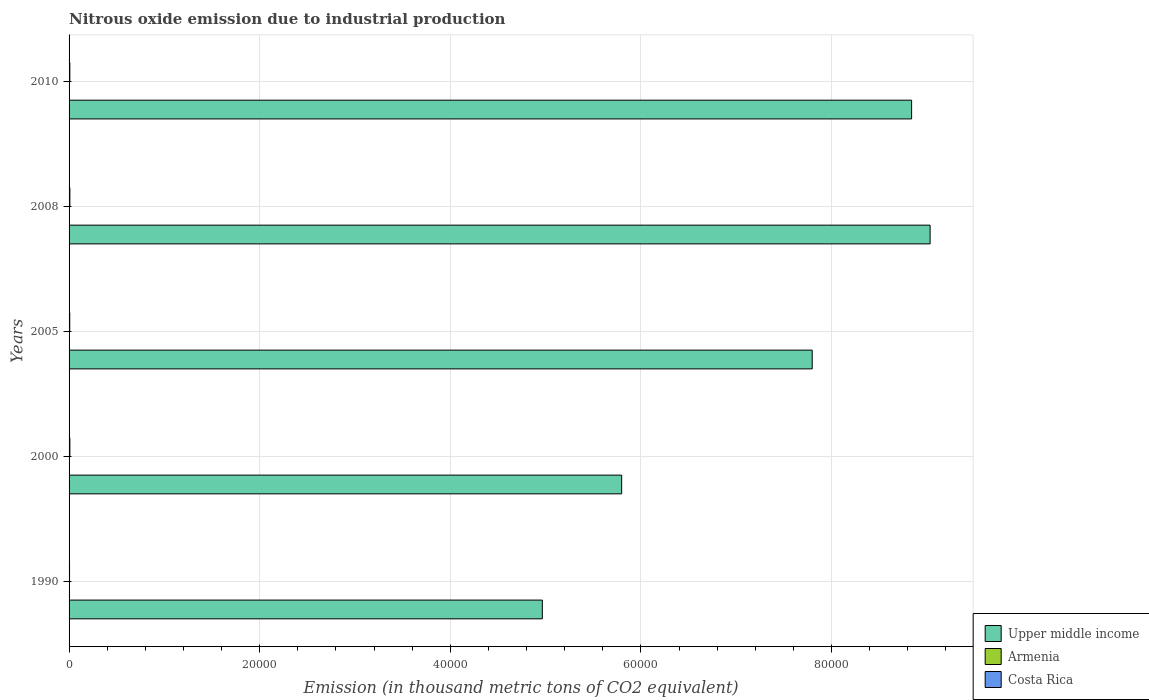How many groups of bars are there?
Provide a succinct answer. 5. Are the number of bars on each tick of the Y-axis equal?
Your answer should be very brief. Yes. How many bars are there on the 3rd tick from the top?
Your answer should be compact. 3. How many bars are there on the 5th tick from the bottom?
Make the answer very short. 3. What is the label of the 2nd group of bars from the top?
Provide a short and direct response. 2008. What is the amount of nitrous oxide emitted in Upper middle income in 2008?
Your response must be concise. 9.03e+04. Across all years, what is the maximum amount of nitrous oxide emitted in Costa Rica?
Provide a succinct answer. 83.4. Across all years, what is the minimum amount of nitrous oxide emitted in Costa Rica?
Your response must be concise. 50.5. What is the total amount of nitrous oxide emitted in Upper middle income in the graph?
Your response must be concise. 3.64e+05. What is the difference between the amount of nitrous oxide emitted in Upper middle income in 2000 and that in 2005?
Your answer should be compact. -2.00e+04. What is the difference between the amount of nitrous oxide emitted in Costa Rica in 2010 and the amount of nitrous oxide emitted in Armenia in 2000?
Your answer should be compact. 75.6. What is the average amount of nitrous oxide emitted in Costa Rica per year?
Give a very brief answer. 73.76. In the year 2008, what is the difference between the amount of nitrous oxide emitted in Costa Rica and amount of nitrous oxide emitted in Armenia?
Ensure brevity in your answer.  59.7. In how many years, is the amount of nitrous oxide emitted in Costa Rica greater than 40000 thousand metric tons?
Ensure brevity in your answer.  0. What is the ratio of the amount of nitrous oxide emitted in Upper middle income in 2000 to that in 2008?
Your response must be concise. 0.64. Is the amount of nitrous oxide emitted in Upper middle income in 1990 less than that in 2005?
Make the answer very short. Yes. Is the difference between the amount of nitrous oxide emitted in Costa Rica in 1990 and 2008 greater than the difference between the amount of nitrous oxide emitted in Armenia in 1990 and 2008?
Offer a very short reply. No. What is the difference between the highest and the second highest amount of nitrous oxide emitted in Armenia?
Keep it short and to the point. 13.3. What is the difference between the highest and the lowest amount of nitrous oxide emitted in Upper middle income?
Provide a succinct answer. 4.07e+04. What does the 2nd bar from the top in 1990 represents?
Offer a terse response. Armenia. What does the 1st bar from the bottom in 2000 represents?
Your answer should be very brief. Upper middle income. Is it the case that in every year, the sum of the amount of nitrous oxide emitted in Armenia and amount of nitrous oxide emitted in Upper middle income is greater than the amount of nitrous oxide emitted in Costa Rica?
Provide a succinct answer. Yes. Are all the bars in the graph horizontal?
Offer a very short reply. Yes. Are the values on the major ticks of X-axis written in scientific E-notation?
Your answer should be compact. No. Does the graph contain any zero values?
Your response must be concise. No. Where does the legend appear in the graph?
Ensure brevity in your answer.  Bottom right. How many legend labels are there?
Offer a very short reply. 3. What is the title of the graph?
Your answer should be very brief. Nitrous oxide emission due to industrial production. Does "Zimbabwe" appear as one of the legend labels in the graph?
Make the answer very short. No. What is the label or title of the X-axis?
Offer a terse response. Emission (in thousand metric tons of CO2 equivalent). What is the label or title of the Y-axis?
Your answer should be very brief. Years. What is the Emission (in thousand metric tons of CO2 equivalent) of Upper middle income in 1990?
Keep it short and to the point. 4.97e+04. What is the Emission (in thousand metric tons of CO2 equivalent) in Costa Rica in 1990?
Keep it short and to the point. 50.5. What is the Emission (in thousand metric tons of CO2 equivalent) of Upper middle income in 2000?
Your answer should be very brief. 5.80e+04. What is the Emission (in thousand metric tons of CO2 equivalent) of Costa Rica in 2000?
Make the answer very short. 83.4. What is the Emission (in thousand metric tons of CO2 equivalent) in Upper middle income in 2005?
Provide a succinct answer. 7.80e+04. What is the Emission (in thousand metric tons of CO2 equivalent) of Armenia in 2005?
Offer a terse response. 5.8. What is the Emission (in thousand metric tons of CO2 equivalent) of Costa Rica in 2005?
Give a very brief answer. 70.7. What is the Emission (in thousand metric tons of CO2 equivalent) of Upper middle income in 2008?
Your answer should be very brief. 9.03e+04. What is the Emission (in thousand metric tons of CO2 equivalent) of Armenia in 2008?
Keep it short and to the point. 23.7. What is the Emission (in thousand metric tons of CO2 equivalent) in Costa Rica in 2008?
Keep it short and to the point. 83.4. What is the Emission (in thousand metric tons of CO2 equivalent) of Upper middle income in 2010?
Provide a short and direct response. 8.84e+04. What is the Emission (in thousand metric tons of CO2 equivalent) of Armenia in 2010?
Provide a succinct answer. 22.8. What is the Emission (in thousand metric tons of CO2 equivalent) of Costa Rica in 2010?
Provide a succinct answer. 80.8. Across all years, what is the maximum Emission (in thousand metric tons of CO2 equivalent) in Upper middle income?
Your answer should be compact. 9.03e+04. Across all years, what is the maximum Emission (in thousand metric tons of CO2 equivalent) of Armenia?
Offer a very short reply. 37. Across all years, what is the maximum Emission (in thousand metric tons of CO2 equivalent) of Costa Rica?
Offer a terse response. 83.4. Across all years, what is the minimum Emission (in thousand metric tons of CO2 equivalent) of Upper middle income?
Keep it short and to the point. 4.97e+04. Across all years, what is the minimum Emission (in thousand metric tons of CO2 equivalent) in Costa Rica?
Offer a very short reply. 50.5. What is the total Emission (in thousand metric tons of CO2 equivalent) of Upper middle income in the graph?
Offer a very short reply. 3.64e+05. What is the total Emission (in thousand metric tons of CO2 equivalent) in Armenia in the graph?
Provide a succinct answer. 94.5. What is the total Emission (in thousand metric tons of CO2 equivalent) in Costa Rica in the graph?
Provide a short and direct response. 368.8. What is the difference between the Emission (in thousand metric tons of CO2 equivalent) of Upper middle income in 1990 and that in 2000?
Your response must be concise. -8322.4. What is the difference between the Emission (in thousand metric tons of CO2 equivalent) in Armenia in 1990 and that in 2000?
Provide a succinct answer. 31.8. What is the difference between the Emission (in thousand metric tons of CO2 equivalent) in Costa Rica in 1990 and that in 2000?
Keep it short and to the point. -32.9. What is the difference between the Emission (in thousand metric tons of CO2 equivalent) in Upper middle income in 1990 and that in 2005?
Ensure brevity in your answer.  -2.83e+04. What is the difference between the Emission (in thousand metric tons of CO2 equivalent) in Armenia in 1990 and that in 2005?
Provide a succinct answer. 31.2. What is the difference between the Emission (in thousand metric tons of CO2 equivalent) in Costa Rica in 1990 and that in 2005?
Provide a short and direct response. -20.2. What is the difference between the Emission (in thousand metric tons of CO2 equivalent) of Upper middle income in 1990 and that in 2008?
Offer a terse response. -4.07e+04. What is the difference between the Emission (in thousand metric tons of CO2 equivalent) of Costa Rica in 1990 and that in 2008?
Your response must be concise. -32.9. What is the difference between the Emission (in thousand metric tons of CO2 equivalent) of Upper middle income in 1990 and that in 2010?
Your answer should be compact. -3.87e+04. What is the difference between the Emission (in thousand metric tons of CO2 equivalent) in Costa Rica in 1990 and that in 2010?
Make the answer very short. -30.3. What is the difference between the Emission (in thousand metric tons of CO2 equivalent) in Upper middle income in 2000 and that in 2005?
Keep it short and to the point. -2.00e+04. What is the difference between the Emission (in thousand metric tons of CO2 equivalent) of Costa Rica in 2000 and that in 2005?
Provide a short and direct response. 12.7. What is the difference between the Emission (in thousand metric tons of CO2 equivalent) of Upper middle income in 2000 and that in 2008?
Your answer should be very brief. -3.24e+04. What is the difference between the Emission (in thousand metric tons of CO2 equivalent) of Armenia in 2000 and that in 2008?
Provide a succinct answer. -18.5. What is the difference between the Emission (in thousand metric tons of CO2 equivalent) in Costa Rica in 2000 and that in 2008?
Give a very brief answer. 0. What is the difference between the Emission (in thousand metric tons of CO2 equivalent) of Upper middle income in 2000 and that in 2010?
Ensure brevity in your answer.  -3.04e+04. What is the difference between the Emission (in thousand metric tons of CO2 equivalent) in Armenia in 2000 and that in 2010?
Make the answer very short. -17.6. What is the difference between the Emission (in thousand metric tons of CO2 equivalent) of Costa Rica in 2000 and that in 2010?
Give a very brief answer. 2.6. What is the difference between the Emission (in thousand metric tons of CO2 equivalent) in Upper middle income in 2005 and that in 2008?
Ensure brevity in your answer.  -1.24e+04. What is the difference between the Emission (in thousand metric tons of CO2 equivalent) in Armenia in 2005 and that in 2008?
Ensure brevity in your answer.  -17.9. What is the difference between the Emission (in thousand metric tons of CO2 equivalent) of Upper middle income in 2005 and that in 2010?
Ensure brevity in your answer.  -1.04e+04. What is the difference between the Emission (in thousand metric tons of CO2 equivalent) of Armenia in 2005 and that in 2010?
Provide a short and direct response. -17. What is the difference between the Emission (in thousand metric tons of CO2 equivalent) of Upper middle income in 2008 and that in 2010?
Your response must be concise. 1941.1. What is the difference between the Emission (in thousand metric tons of CO2 equivalent) in Upper middle income in 1990 and the Emission (in thousand metric tons of CO2 equivalent) in Armenia in 2000?
Your answer should be very brief. 4.96e+04. What is the difference between the Emission (in thousand metric tons of CO2 equivalent) of Upper middle income in 1990 and the Emission (in thousand metric tons of CO2 equivalent) of Costa Rica in 2000?
Offer a very short reply. 4.96e+04. What is the difference between the Emission (in thousand metric tons of CO2 equivalent) in Armenia in 1990 and the Emission (in thousand metric tons of CO2 equivalent) in Costa Rica in 2000?
Keep it short and to the point. -46.4. What is the difference between the Emission (in thousand metric tons of CO2 equivalent) in Upper middle income in 1990 and the Emission (in thousand metric tons of CO2 equivalent) in Armenia in 2005?
Give a very brief answer. 4.96e+04. What is the difference between the Emission (in thousand metric tons of CO2 equivalent) in Upper middle income in 1990 and the Emission (in thousand metric tons of CO2 equivalent) in Costa Rica in 2005?
Offer a very short reply. 4.96e+04. What is the difference between the Emission (in thousand metric tons of CO2 equivalent) of Armenia in 1990 and the Emission (in thousand metric tons of CO2 equivalent) of Costa Rica in 2005?
Your answer should be very brief. -33.7. What is the difference between the Emission (in thousand metric tons of CO2 equivalent) in Upper middle income in 1990 and the Emission (in thousand metric tons of CO2 equivalent) in Armenia in 2008?
Give a very brief answer. 4.96e+04. What is the difference between the Emission (in thousand metric tons of CO2 equivalent) of Upper middle income in 1990 and the Emission (in thousand metric tons of CO2 equivalent) of Costa Rica in 2008?
Make the answer very short. 4.96e+04. What is the difference between the Emission (in thousand metric tons of CO2 equivalent) in Armenia in 1990 and the Emission (in thousand metric tons of CO2 equivalent) in Costa Rica in 2008?
Make the answer very short. -46.4. What is the difference between the Emission (in thousand metric tons of CO2 equivalent) in Upper middle income in 1990 and the Emission (in thousand metric tons of CO2 equivalent) in Armenia in 2010?
Keep it short and to the point. 4.96e+04. What is the difference between the Emission (in thousand metric tons of CO2 equivalent) in Upper middle income in 1990 and the Emission (in thousand metric tons of CO2 equivalent) in Costa Rica in 2010?
Make the answer very short. 4.96e+04. What is the difference between the Emission (in thousand metric tons of CO2 equivalent) in Armenia in 1990 and the Emission (in thousand metric tons of CO2 equivalent) in Costa Rica in 2010?
Give a very brief answer. -43.8. What is the difference between the Emission (in thousand metric tons of CO2 equivalent) of Upper middle income in 2000 and the Emission (in thousand metric tons of CO2 equivalent) of Armenia in 2005?
Provide a short and direct response. 5.80e+04. What is the difference between the Emission (in thousand metric tons of CO2 equivalent) of Upper middle income in 2000 and the Emission (in thousand metric tons of CO2 equivalent) of Costa Rica in 2005?
Keep it short and to the point. 5.79e+04. What is the difference between the Emission (in thousand metric tons of CO2 equivalent) of Armenia in 2000 and the Emission (in thousand metric tons of CO2 equivalent) of Costa Rica in 2005?
Ensure brevity in your answer.  -65.5. What is the difference between the Emission (in thousand metric tons of CO2 equivalent) of Upper middle income in 2000 and the Emission (in thousand metric tons of CO2 equivalent) of Armenia in 2008?
Your response must be concise. 5.80e+04. What is the difference between the Emission (in thousand metric tons of CO2 equivalent) in Upper middle income in 2000 and the Emission (in thousand metric tons of CO2 equivalent) in Costa Rica in 2008?
Make the answer very short. 5.79e+04. What is the difference between the Emission (in thousand metric tons of CO2 equivalent) in Armenia in 2000 and the Emission (in thousand metric tons of CO2 equivalent) in Costa Rica in 2008?
Your answer should be very brief. -78.2. What is the difference between the Emission (in thousand metric tons of CO2 equivalent) in Upper middle income in 2000 and the Emission (in thousand metric tons of CO2 equivalent) in Armenia in 2010?
Your answer should be compact. 5.80e+04. What is the difference between the Emission (in thousand metric tons of CO2 equivalent) in Upper middle income in 2000 and the Emission (in thousand metric tons of CO2 equivalent) in Costa Rica in 2010?
Keep it short and to the point. 5.79e+04. What is the difference between the Emission (in thousand metric tons of CO2 equivalent) in Armenia in 2000 and the Emission (in thousand metric tons of CO2 equivalent) in Costa Rica in 2010?
Provide a succinct answer. -75.6. What is the difference between the Emission (in thousand metric tons of CO2 equivalent) of Upper middle income in 2005 and the Emission (in thousand metric tons of CO2 equivalent) of Armenia in 2008?
Offer a terse response. 7.79e+04. What is the difference between the Emission (in thousand metric tons of CO2 equivalent) of Upper middle income in 2005 and the Emission (in thousand metric tons of CO2 equivalent) of Costa Rica in 2008?
Provide a short and direct response. 7.79e+04. What is the difference between the Emission (in thousand metric tons of CO2 equivalent) of Armenia in 2005 and the Emission (in thousand metric tons of CO2 equivalent) of Costa Rica in 2008?
Keep it short and to the point. -77.6. What is the difference between the Emission (in thousand metric tons of CO2 equivalent) in Upper middle income in 2005 and the Emission (in thousand metric tons of CO2 equivalent) in Armenia in 2010?
Keep it short and to the point. 7.79e+04. What is the difference between the Emission (in thousand metric tons of CO2 equivalent) in Upper middle income in 2005 and the Emission (in thousand metric tons of CO2 equivalent) in Costa Rica in 2010?
Provide a succinct answer. 7.79e+04. What is the difference between the Emission (in thousand metric tons of CO2 equivalent) of Armenia in 2005 and the Emission (in thousand metric tons of CO2 equivalent) of Costa Rica in 2010?
Offer a terse response. -75. What is the difference between the Emission (in thousand metric tons of CO2 equivalent) of Upper middle income in 2008 and the Emission (in thousand metric tons of CO2 equivalent) of Armenia in 2010?
Provide a succinct answer. 9.03e+04. What is the difference between the Emission (in thousand metric tons of CO2 equivalent) in Upper middle income in 2008 and the Emission (in thousand metric tons of CO2 equivalent) in Costa Rica in 2010?
Make the answer very short. 9.03e+04. What is the difference between the Emission (in thousand metric tons of CO2 equivalent) of Armenia in 2008 and the Emission (in thousand metric tons of CO2 equivalent) of Costa Rica in 2010?
Your answer should be very brief. -57.1. What is the average Emission (in thousand metric tons of CO2 equivalent) of Upper middle income per year?
Your answer should be very brief. 7.29e+04. What is the average Emission (in thousand metric tons of CO2 equivalent) in Costa Rica per year?
Your answer should be compact. 73.76. In the year 1990, what is the difference between the Emission (in thousand metric tons of CO2 equivalent) in Upper middle income and Emission (in thousand metric tons of CO2 equivalent) in Armenia?
Make the answer very short. 4.96e+04. In the year 1990, what is the difference between the Emission (in thousand metric tons of CO2 equivalent) of Upper middle income and Emission (in thousand metric tons of CO2 equivalent) of Costa Rica?
Your answer should be very brief. 4.96e+04. In the year 1990, what is the difference between the Emission (in thousand metric tons of CO2 equivalent) in Armenia and Emission (in thousand metric tons of CO2 equivalent) in Costa Rica?
Make the answer very short. -13.5. In the year 2000, what is the difference between the Emission (in thousand metric tons of CO2 equivalent) in Upper middle income and Emission (in thousand metric tons of CO2 equivalent) in Armenia?
Offer a very short reply. 5.80e+04. In the year 2000, what is the difference between the Emission (in thousand metric tons of CO2 equivalent) in Upper middle income and Emission (in thousand metric tons of CO2 equivalent) in Costa Rica?
Provide a succinct answer. 5.79e+04. In the year 2000, what is the difference between the Emission (in thousand metric tons of CO2 equivalent) of Armenia and Emission (in thousand metric tons of CO2 equivalent) of Costa Rica?
Offer a very short reply. -78.2. In the year 2005, what is the difference between the Emission (in thousand metric tons of CO2 equivalent) in Upper middle income and Emission (in thousand metric tons of CO2 equivalent) in Armenia?
Keep it short and to the point. 7.80e+04. In the year 2005, what is the difference between the Emission (in thousand metric tons of CO2 equivalent) of Upper middle income and Emission (in thousand metric tons of CO2 equivalent) of Costa Rica?
Your answer should be compact. 7.79e+04. In the year 2005, what is the difference between the Emission (in thousand metric tons of CO2 equivalent) of Armenia and Emission (in thousand metric tons of CO2 equivalent) of Costa Rica?
Give a very brief answer. -64.9. In the year 2008, what is the difference between the Emission (in thousand metric tons of CO2 equivalent) of Upper middle income and Emission (in thousand metric tons of CO2 equivalent) of Armenia?
Keep it short and to the point. 9.03e+04. In the year 2008, what is the difference between the Emission (in thousand metric tons of CO2 equivalent) in Upper middle income and Emission (in thousand metric tons of CO2 equivalent) in Costa Rica?
Ensure brevity in your answer.  9.03e+04. In the year 2008, what is the difference between the Emission (in thousand metric tons of CO2 equivalent) in Armenia and Emission (in thousand metric tons of CO2 equivalent) in Costa Rica?
Make the answer very short. -59.7. In the year 2010, what is the difference between the Emission (in thousand metric tons of CO2 equivalent) in Upper middle income and Emission (in thousand metric tons of CO2 equivalent) in Armenia?
Your response must be concise. 8.84e+04. In the year 2010, what is the difference between the Emission (in thousand metric tons of CO2 equivalent) in Upper middle income and Emission (in thousand metric tons of CO2 equivalent) in Costa Rica?
Provide a short and direct response. 8.83e+04. In the year 2010, what is the difference between the Emission (in thousand metric tons of CO2 equivalent) in Armenia and Emission (in thousand metric tons of CO2 equivalent) in Costa Rica?
Ensure brevity in your answer.  -58. What is the ratio of the Emission (in thousand metric tons of CO2 equivalent) of Upper middle income in 1990 to that in 2000?
Make the answer very short. 0.86. What is the ratio of the Emission (in thousand metric tons of CO2 equivalent) in Armenia in 1990 to that in 2000?
Offer a very short reply. 7.12. What is the ratio of the Emission (in thousand metric tons of CO2 equivalent) in Costa Rica in 1990 to that in 2000?
Provide a short and direct response. 0.61. What is the ratio of the Emission (in thousand metric tons of CO2 equivalent) of Upper middle income in 1990 to that in 2005?
Your answer should be compact. 0.64. What is the ratio of the Emission (in thousand metric tons of CO2 equivalent) in Armenia in 1990 to that in 2005?
Your response must be concise. 6.38. What is the ratio of the Emission (in thousand metric tons of CO2 equivalent) in Upper middle income in 1990 to that in 2008?
Offer a very short reply. 0.55. What is the ratio of the Emission (in thousand metric tons of CO2 equivalent) of Armenia in 1990 to that in 2008?
Give a very brief answer. 1.56. What is the ratio of the Emission (in thousand metric tons of CO2 equivalent) in Costa Rica in 1990 to that in 2008?
Your response must be concise. 0.61. What is the ratio of the Emission (in thousand metric tons of CO2 equivalent) in Upper middle income in 1990 to that in 2010?
Ensure brevity in your answer.  0.56. What is the ratio of the Emission (in thousand metric tons of CO2 equivalent) of Armenia in 1990 to that in 2010?
Provide a succinct answer. 1.62. What is the ratio of the Emission (in thousand metric tons of CO2 equivalent) in Upper middle income in 2000 to that in 2005?
Give a very brief answer. 0.74. What is the ratio of the Emission (in thousand metric tons of CO2 equivalent) in Armenia in 2000 to that in 2005?
Your answer should be compact. 0.9. What is the ratio of the Emission (in thousand metric tons of CO2 equivalent) of Costa Rica in 2000 to that in 2005?
Offer a terse response. 1.18. What is the ratio of the Emission (in thousand metric tons of CO2 equivalent) in Upper middle income in 2000 to that in 2008?
Your response must be concise. 0.64. What is the ratio of the Emission (in thousand metric tons of CO2 equivalent) of Armenia in 2000 to that in 2008?
Your response must be concise. 0.22. What is the ratio of the Emission (in thousand metric tons of CO2 equivalent) in Upper middle income in 2000 to that in 2010?
Offer a terse response. 0.66. What is the ratio of the Emission (in thousand metric tons of CO2 equivalent) of Armenia in 2000 to that in 2010?
Provide a succinct answer. 0.23. What is the ratio of the Emission (in thousand metric tons of CO2 equivalent) in Costa Rica in 2000 to that in 2010?
Ensure brevity in your answer.  1.03. What is the ratio of the Emission (in thousand metric tons of CO2 equivalent) of Upper middle income in 2005 to that in 2008?
Provide a short and direct response. 0.86. What is the ratio of the Emission (in thousand metric tons of CO2 equivalent) of Armenia in 2005 to that in 2008?
Your response must be concise. 0.24. What is the ratio of the Emission (in thousand metric tons of CO2 equivalent) in Costa Rica in 2005 to that in 2008?
Offer a very short reply. 0.85. What is the ratio of the Emission (in thousand metric tons of CO2 equivalent) in Upper middle income in 2005 to that in 2010?
Offer a very short reply. 0.88. What is the ratio of the Emission (in thousand metric tons of CO2 equivalent) of Armenia in 2005 to that in 2010?
Offer a very short reply. 0.25. What is the ratio of the Emission (in thousand metric tons of CO2 equivalent) of Costa Rica in 2005 to that in 2010?
Give a very brief answer. 0.88. What is the ratio of the Emission (in thousand metric tons of CO2 equivalent) in Upper middle income in 2008 to that in 2010?
Keep it short and to the point. 1.02. What is the ratio of the Emission (in thousand metric tons of CO2 equivalent) in Armenia in 2008 to that in 2010?
Your answer should be very brief. 1.04. What is the ratio of the Emission (in thousand metric tons of CO2 equivalent) of Costa Rica in 2008 to that in 2010?
Offer a terse response. 1.03. What is the difference between the highest and the second highest Emission (in thousand metric tons of CO2 equivalent) in Upper middle income?
Ensure brevity in your answer.  1941.1. What is the difference between the highest and the second highest Emission (in thousand metric tons of CO2 equivalent) in Costa Rica?
Provide a short and direct response. 0. What is the difference between the highest and the lowest Emission (in thousand metric tons of CO2 equivalent) of Upper middle income?
Your response must be concise. 4.07e+04. What is the difference between the highest and the lowest Emission (in thousand metric tons of CO2 equivalent) of Armenia?
Provide a succinct answer. 31.8. What is the difference between the highest and the lowest Emission (in thousand metric tons of CO2 equivalent) in Costa Rica?
Keep it short and to the point. 32.9. 